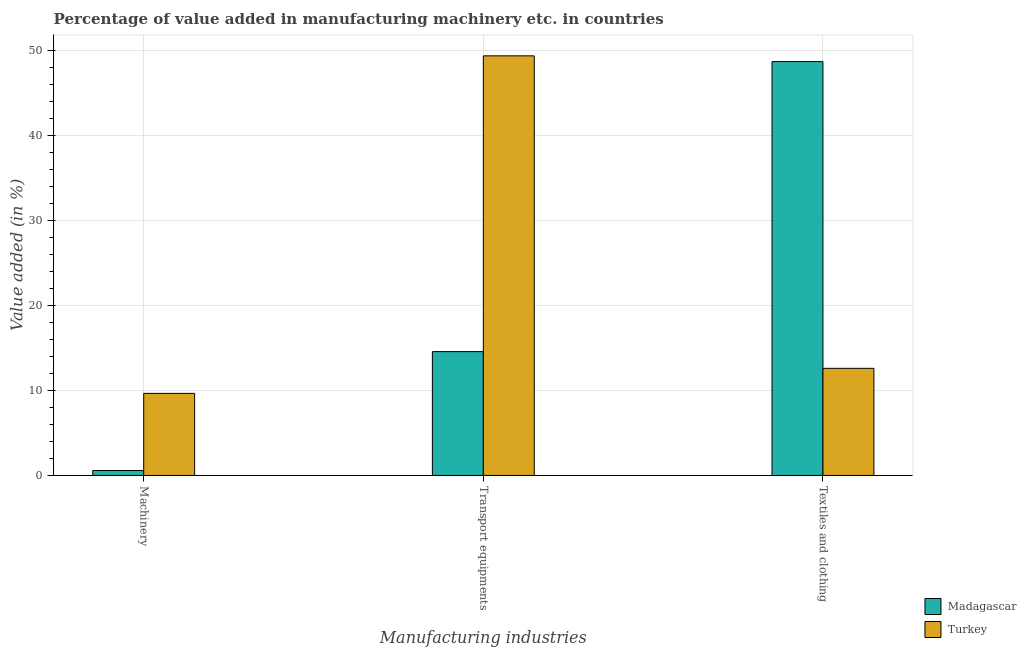How many different coloured bars are there?
Keep it short and to the point. 2. Are the number of bars per tick equal to the number of legend labels?
Your response must be concise. Yes. How many bars are there on the 1st tick from the right?
Ensure brevity in your answer.  2. What is the label of the 1st group of bars from the left?
Your response must be concise. Machinery. What is the value added in manufacturing machinery in Madagascar?
Your answer should be very brief. 0.58. Across all countries, what is the maximum value added in manufacturing machinery?
Give a very brief answer. 9.65. Across all countries, what is the minimum value added in manufacturing transport equipments?
Your response must be concise. 14.55. In which country was the value added in manufacturing transport equipments minimum?
Provide a short and direct response. Madagascar. What is the total value added in manufacturing textile and clothing in the graph?
Give a very brief answer. 61.24. What is the difference between the value added in manufacturing textile and clothing in Madagascar and that in Turkey?
Give a very brief answer. 36.06. What is the difference between the value added in manufacturing transport equipments in Madagascar and the value added in manufacturing machinery in Turkey?
Offer a terse response. 4.91. What is the average value added in manufacturing textile and clothing per country?
Your answer should be very brief. 30.62. What is the difference between the value added in manufacturing textile and clothing and value added in manufacturing transport equipments in Madagascar?
Offer a terse response. 34.09. What is the ratio of the value added in manufacturing transport equipments in Madagascar to that in Turkey?
Ensure brevity in your answer.  0.3. Is the value added in manufacturing textile and clothing in Madagascar less than that in Turkey?
Your answer should be compact. No. Is the difference between the value added in manufacturing textile and clothing in Madagascar and Turkey greater than the difference between the value added in manufacturing machinery in Madagascar and Turkey?
Your response must be concise. Yes. What is the difference between the highest and the second highest value added in manufacturing transport equipments?
Ensure brevity in your answer.  34.77. What is the difference between the highest and the lowest value added in manufacturing machinery?
Provide a short and direct response. 9.06. Is the sum of the value added in manufacturing machinery in Turkey and Madagascar greater than the maximum value added in manufacturing transport equipments across all countries?
Your answer should be compact. No. What does the 1st bar from the left in Transport equipments represents?
Your answer should be compact. Madagascar. What does the 2nd bar from the right in Textiles and clothing represents?
Offer a terse response. Madagascar. Is it the case that in every country, the sum of the value added in manufacturing machinery and value added in manufacturing transport equipments is greater than the value added in manufacturing textile and clothing?
Your answer should be compact. No. What is the difference between two consecutive major ticks on the Y-axis?
Provide a succinct answer. 10. Does the graph contain grids?
Your answer should be very brief. Yes. What is the title of the graph?
Your answer should be very brief. Percentage of value added in manufacturing machinery etc. in countries. What is the label or title of the X-axis?
Your answer should be very brief. Manufacturing industries. What is the label or title of the Y-axis?
Your answer should be compact. Value added (in %). What is the Value added (in %) in Madagascar in Machinery?
Offer a terse response. 0.58. What is the Value added (in %) in Turkey in Machinery?
Provide a short and direct response. 9.65. What is the Value added (in %) in Madagascar in Transport equipments?
Ensure brevity in your answer.  14.55. What is the Value added (in %) of Turkey in Transport equipments?
Your response must be concise. 49.32. What is the Value added (in %) in Madagascar in Textiles and clothing?
Provide a succinct answer. 48.65. What is the Value added (in %) of Turkey in Textiles and clothing?
Ensure brevity in your answer.  12.59. Across all Manufacturing industries, what is the maximum Value added (in %) of Madagascar?
Make the answer very short. 48.65. Across all Manufacturing industries, what is the maximum Value added (in %) in Turkey?
Offer a terse response. 49.32. Across all Manufacturing industries, what is the minimum Value added (in %) of Madagascar?
Ensure brevity in your answer.  0.58. Across all Manufacturing industries, what is the minimum Value added (in %) of Turkey?
Make the answer very short. 9.65. What is the total Value added (in %) in Madagascar in the graph?
Offer a terse response. 63.78. What is the total Value added (in %) of Turkey in the graph?
Offer a very short reply. 71.56. What is the difference between the Value added (in %) of Madagascar in Machinery and that in Transport equipments?
Your answer should be compact. -13.97. What is the difference between the Value added (in %) in Turkey in Machinery and that in Transport equipments?
Ensure brevity in your answer.  -39.68. What is the difference between the Value added (in %) of Madagascar in Machinery and that in Textiles and clothing?
Give a very brief answer. -48.07. What is the difference between the Value added (in %) in Turkey in Machinery and that in Textiles and clothing?
Give a very brief answer. -2.95. What is the difference between the Value added (in %) of Madagascar in Transport equipments and that in Textiles and clothing?
Give a very brief answer. -34.09. What is the difference between the Value added (in %) in Turkey in Transport equipments and that in Textiles and clothing?
Provide a succinct answer. 36.73. What is the difference between the Value added (in %) of Madagascar in Machinery and the Value added (in %) of Turkey in Transport equipments?
Your answer should be very brief. -48.74. What is the difference between the Value added (in %) of Madagascar in Machinery and the Value added (in %) of Turkey in Textiles and clothing?
Provide a succinct answer. -12.01. What is the difference between the Value added (in %) in Madagascar in Transport equipments and the Value added (in %) in Turkey in Textiles and clothing?
Ensure brevity in your answer.  1.96. What is the average Value added (in %) in Madagascar per Manufacturing industries?
Make the answer very short. 21.26. What is the average Value added (in %) of Turkey per Manufacturing industries?
Offer a very short reply. 23.85. What is the difference between the Value added (in %) of Madagascar and Value added (in %) of Turkey in Machinery?
Your response must be concise. -9.06. What is the difference between the Value added (in %) of Madagascar and Value added (in %) of Turkey in Transport equipments?
Provide a succinct answer. -34.77. What is the difference between the Value added (in %) of Madagascar and Value added (in %) of Turkey in Textiles and clothing?
Offer a very short reply. 36.06. What is the ratio of the Value added (in %) of Madagascar in Machinery to that in Transport equipments?
Your response must be concise. 0.04. What is the ratio of the Value added (in %) in Turkey in Machinery to that in Transport equipments?
Your response must be concise. 0.2. What is the ratio of the Value added (in %) of Madagascar in Machinery to that in Textiles and clothing?
Give a very brief answer. 0.01. What is the ratio of the Value added (in %) of Turkey in Machinery to that in Textiles and clothing?
Ensure brevity in your answer.  0.77. What is the ratio of the Value added (in %) of Madagascar in Transport equipments to that in Textiles and clothing?
Keep it short and to the point. 0.3. What is the ratio of the Value added (in %) in Turkey in Transport equipments to that in Textiles and clothing?
Provide a short and direct response. 3.92. What is the difference between the highest and the second highest Value added (in %) of Madagascar?
Provide a short and direct response. 34.09. What is the difference between the highest and the second highest Value added (in %) in Turkey?
Your response must be concise. 36.73. What is the difference between the highest and the lowest Value added (in %) of Madagascar?
Give a very brief answer. 48.07. What is the difference between the highest and the lowest Value added (in %) in Turkey?
Ensure brevity in your answer.  39.68. 